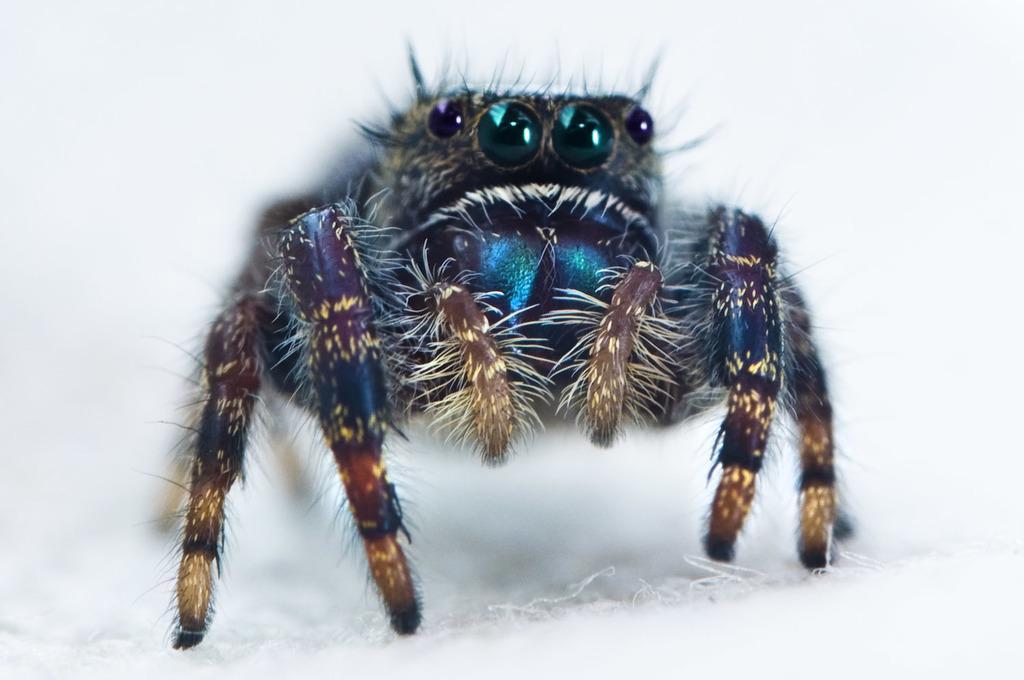How would you summarize this image in a sentence or two? In this image I can see an insect which is colorful. It is on the white color surface. 